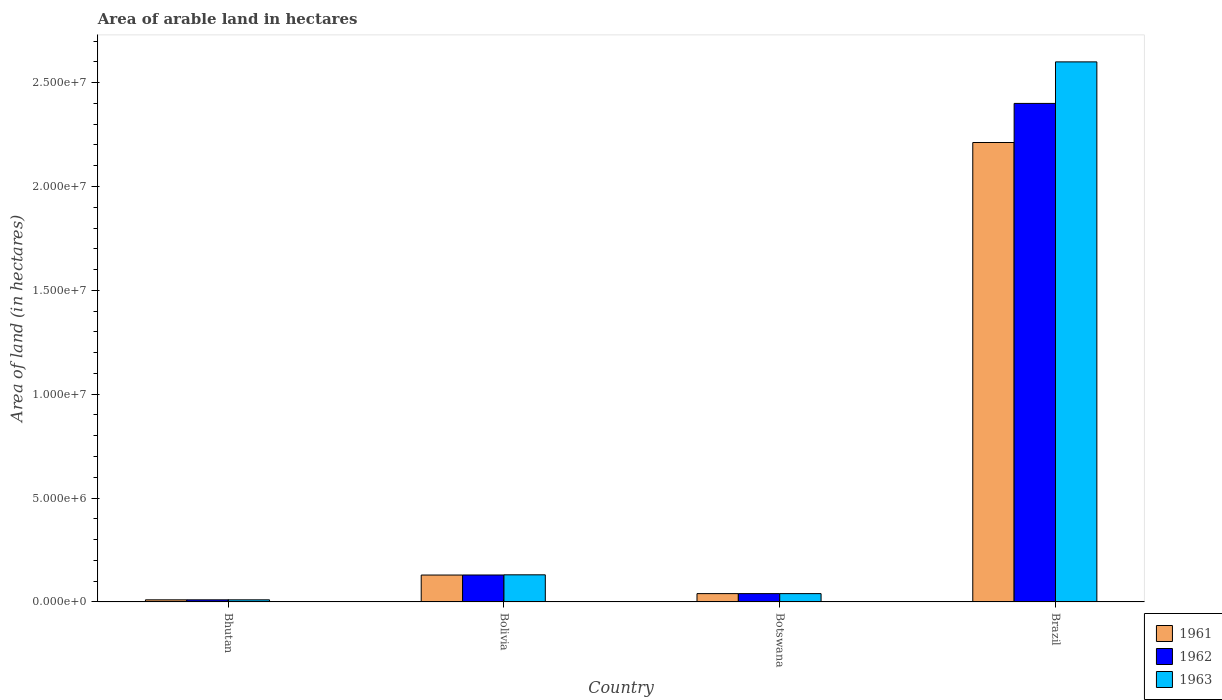How many groups of bars are there?
Offer a very short reply. 4. Are the number of bars per tick equal to the number of legend labels?
Keep it short and to the point. Yes. Are the number of bars on each tick of the X-axis equal?
Your answer should be compact. Yes. How many bars are there on the 1st tick from the right?
Your response must be concise. 3. What is the label of the 2nd group of bars from the left?
Provide a short and direct response. Bolivia. In how many cases, is the number of bars for a given country not equal to the number of legend labels?
Give a very brief answer. 0. What is the total arable land in 1963 in Botswana?
Keep it short and to the point. 3.99e+05. Across all countries, what is the maximum total arable land in 1963?
Give a very brief answer. 2.60e+07. In which country was the total arable land in 1962 minimum?
Keep it short and to the point. Bhutan. What is the total total arable land in 1962 in the graph?
Give a very brief answer. 2.58e+07. What is the difference between the total arable land in 1963 in Bolivia and that in Brazil?
Give a very brief answer. -2.47e+07. What is the difference between the total arable land in 1962 in Brazil and the total arable land in 1961 in Bhutan?
Ensure brevity in your answer.  2.39e+07. What is the average total arable land in 1962 per country?
Provide a succinct answer. 6.45e+06. What is the ratio of the total arable land in 1963 in Bhutan to that in Botswana?
Make the answer very short. 0.25. Is the total arable land in 1962 in Bolivia less than that in Botswana?
Provide a short and direct response. No. What is the difference between the highest and the second highest total arable land in 1962?
Your answer should be compact. 2.27e+07. What is the difference between the highest and the lowest total arable land in 1962?
Provide a short and direct response. 2.39e+07. Is the sum of the total arable land in 1963 in Botswana and Brazil greater than the maximum total arable land in 1961 across all countries?
Make the answer very short. Yes. What does the 1st bar from the right in Brazil represents?
Offer a very short reply. 1963. Are all the bars in the graph horizontal?
Provide a succinct answer. No. Are the values on the major ticks of Y-axis written in scientific E-notation?
Give a very brief answer. Yes. Does the graph contain any zero values?
Ensure brevity in your answer.  No. Where does the legend appear in the graph?
Make the answer very short. Bottom right. What is the title of the graph?
Ensure brevity in your answer.  Area of arable land in hectares. Does "2014" appear as one of the legend labels in the graph?
Your answer should be compact. No. What is the label or title of the Y-axis?
Provide a short and direct response. Area of land (in hectares). What is the Area of land (in hectares) of 1961 in Bhutan?
Your answer should be compact. 1.00e+05. What is the Area of land (in hectares) of 1962 in Bhutan?
Provide a succinct answer. 1.00e+05. What is the Area of land (in hectares) in 1961 in Bolivia?
Ensure brevity in your answer.  1.29e+06. What is the Area of land (in hectares) in 1962 in Bolivia?
Keep it short and to the point. 1.30e+06. What is the Area of land (in hectares) of 1963 in Bolivia?
Your response must be concise. 1.30e+06. What is the Area of land (in hectares) of 1961 in Botswana?
Your answer should be very brief. 3.99e+05. What is the Area of land (in hectares) of 1962 in Botswana?
Provide a succinct answer. 3.99e+05. What is the Area of land (in hectares) in 1963 in Botswana?
Make the answer very short. 3.99e+05. What is the Area of land (in hectares) of 1961 in Brazil?
Ensure brevity in your answer.  2.21e+07. What is the Area of land (in hectares) in 1962 in Brazil?
Provide a succinct answer. 2.40e+07. What is the Area of land (in hectares) in 1963 in Brazil?
Offer a very short reply. 2.60e+07. Across all countries, what is the maximum Area of land (in hectares) in 1961?
Offer a terse response. 2.21e+07. Across all countries, what is the maximum Area of land (in hectares) of 1962?
Keep it short and to the point. 2.40e+07. Across all countries, what is the maximum Area of land (in hectares) in 1963?
Ensure brevity in your answer.  2.60e+07. What is the total Area of land (in hectares) in 1961 in the graph?
Your answer should be compact. 2.39e+07. What is the total Area of land (in hectares) in 1962 in the graph?
Give a very brief answer. 2.58e+07. What is the total Area of land (in hectares) in 1963 in the graph?
Ensure brevity in your answer.  2.78e+07. What is the difference between the Area of land (in hectares) in 1961 in Bhutan and that in Bolivia?
Ensure brevity in your answer.  -1.19e+06. What is the difference between the Area of land (in hectares) of 1962 in Bhutan and that in Bolivia?
Offer a very short reply. -1.20e+06. What is the difference between the Area of land (in hectares) in 1963 in Bhutan and that in Bolivia?
Provide a succinct answer. -1.20e+06. What is the difference between the Area of land (in hectares) in 1961 in Bhutan and that in Botswana?
Your answer should be very brief. -2.99e+05. What is the difference between the Area of land (in hectares) of 1962 in Bhutan and that in Botswana?
Provide a short and direct response. -2.99e+05. What is the difference between the Area of land (in hectares) of 1963 in Bhutan and that in Botswana?
Offer a very short reply. -2.99e+05. What is the difference between the Area of land (in hectares) of 1961 in Bhutan and that in Brazil?
Give a very brief answer. -2.20e+07. What is the difference between the Area of land (in hectares) of 1962 in Bhutan and that in Brazil?
Provide a short and direct response. -2.39e+07. What is the difference between the Area of land (in hectares) of 1963 in Bhutan and that in Brazil?
Make the answer very short. -2.59e+07. What is the difference between the Area of land (in hectares) of 1961 in Bolivia and that in Botswana?
Your answer should be compact. 8.95e+05. What is the difference between the Area of land (in hectares) in 1962 in Bolivia and that in Botswana?
Provide a succinct answer. 8.97e+05. What is the difference between the Area of land (in hectares) in 1963 in Bolivia and that in Botswana?
Offer a terse response. 9.05e+05. What is the difference between the Area of land (in hectares) in 1961 in Bolivia and that in Brazil?
Your response must be concise. -2.08e+07. What is the difference between the Area of land (in hectares) in 1962 in Bolivia and that in Brazil?
Give a very brief answer. -2.27e+07. What is the difference between the Area of land (in hectares) of 1963 in Bolivia and that in Brazil?
Provide a short and direct response. -2.47e+07. What is the difference between the Area of land (in hectares) of 1961 in Botswana and that in Brazil?
Your answer should be compact. -2.17e+07. What is the difference between the Area of land (in hectares) of 1962 in Botswana and that in Brazil?
Your answer should be very brief. -2.36e+07. What is the difference between the Area of land (in hectares) in 1963 in Botswana and that in Brazil?
Make the answer very short. -2.56e+07. What is the difference between the Area of land (in hectares) of 1961 in Bhutan and the Area of land (in hectares) of 1962 in Bolivia?
Your answer should be compact. -1.20e+06. What is the difference between the Area of land (in hectares) in 1961 in Bhutan and the Area of land (in hectares) in 1963 in Bolivia?
Give a very brief answer. -1.20e+06. What is the difference between the Area of land (in hectares) of 1962 in Bhutan and the Area of land (in hectares) of 1963 in Bolivia?
Provide a short and direct response. -1.20e+06. What is the difference between the Area of land (in hectares) in 1961 in Bhutan and the Area of land (in hectares) in 1962 in Botswana?
Provide a succinct answer. -2.99e+05. What is the difference between the Area of land (in hectares) of 1961 in Bhutan and the Area of land (in hectares) of 1963 in Botswana?
Give a very brief answer. -2.99e+05. What is the difference between the Area of land (in hectares) of 1962 in Bhutan and the Area of land (in hectares) of 1963 in Botswana?
Give a very brief answer. -2.99e+05. What is the difference between the Area of land (in hectares) of 1961 in Bhutan and the Area of land (in hectares) of 1962 in Brazil?
Provide a short and direct response. -2.39e+07. What is the difference between the Area of land (in hectares) of 1961 in Bhutan and the Area of land (in hectares) of 1963 in Brazil?
Ensure brevity in your answer.  -2.59e+07. What is the difference between the Area of land (in hectares) of 1962 in Bhutan and the Area of land (in hectares) of 1963 in Brazil?
Offer a terse response. -2.59e+07. What is the difference between the Area of land (in hectares) in 1961 in Bolivia and the Area of land (in hectares) in 1962 in Botswana?
Provide a succinct answer. 8.95e+05. What is the difference between the Area of land (in hectares) in 1961 in Bolivia and the Area of land (in hectares) in 1963 in Botswana?
Keep it short and to the point. 8.95e+05. What is the difference between the Area of land (in hectares) of 1962 in Bolivia and the Area of land (in hectares) of 1963 in Botswana?
Ensure brevity in your answer.  8.97e+05. What is the difference between the Area of land (in hectares) in 1961 in Bolivia and the Area of land (in hectares) in 1962 in Brazil?
Keep it short and to the point. -2.27e+07. What is the difference between the Area of land (in hectares) of 1961 in Bolivia and the Area of land (in hectares) of 1963 in Brazil?
Provide a succinct answer. -2.47e+07. What is the difference between the Area of land (in hectares) in 1962 in Bolivia and the Area of land (in hectares) in 1963 in Brazil?
Make the answer very short. -2.47e+07. What is the difference between the Area of land (in hectares) of 1961 in Botswana and the Area of land (in hectares) of 1962 in Brazil?
Make the answer very short. -2.36e+07. What is the difference between the Area of land (in hectares) in 1961 in Botswana and the Area of land (in hectares) in 1963 in Brazil?
Make the answer very short. -2.56e+07. What is the difference between the Area of land (in hectares) in 1962 in Botswana and the Area of land (in hectares) in 1963 in Brazil?
Provide a short and direct response. -2.56e+07. What is the average Area of land (in hectares) in 1961 per country?
Offer a very short reply. 5.98e+06. What is the average Area of land (in hectares) of 1962 per country?
Provide a short and direct response. 6.45e+06. What is the average Area of land (in hectares) of 1963 per country?
Give a very brief answer. 6.95e+06. What is the difference between the Area of land (in hectares) of 1961 and Area of land (in hectares) of 1962 in Bhutan?
Provide a succinct answer. 0. What is the difference between the Area of land (in hectares) of 1962 and Area of land (in hectares) of 1963 in Bhutan?
Offer a terse response. 0. What is the difference between the Area of land (in hectares) of 1961 and Area of land (in hectares) of 1962 in Bolivia?
Your answer should be very brief. -2000. What is the difference between the Area of land (in hectares) of 1961 and Area of land (in hectares) of 1963 in Bolivia?
Keep it short and to the point. -10000. What is the difference between the Area of land (in hectares) of 1962 and Area of land (in hectares) of 1963 in Bolivia?
Offer a very short reply. -8000. What is the difference between the Area of land (in hectares) of 1961 and Area of land (in hectares) of 1962 in Botswana?
Provide a short and direct response. 0. What is the difference between the Area of land (in hectares) in 1961 and Area of land (in hectares) in 1963 in Botswana?
Your response must be concise. 0. What is the difference between the Area of land (in hectares) of 1961 and Area of land (in hectares) of 1962 in Brazil?
Your answer should be compact. -1.88e+06. What is the difference between the Area of land (in hectares) in 1961 and Area of land (in hectares) in 1963 in Brazil?
Your answer should be compact. -3.88e+06. What is the ratio of the Area of land (in hectares) of 1961 in Bhutan to that in Bolivia?
Your answer should be very brief. 0.08. What is the ratio of the Area of land (in hectares) in 1962 in Bhutan to that in Bolivia?
Provide a succinct answer. 0.08. What is the ratio of the Area of land (in hectares) of 1963 in Bhutan to that in Bolivia?
Your response must be concise. 0.08. What is the ratio of the Area of land (in hectares) of 1961 in Bhutan to that in Botswana?
Offer a terse response. 0.25. What is the ratio of the Area of land (in hectares) in 1962 in Bhutan to that in Botswana?
Offer a terse response. 0.25. What is the ratio of the Area of land (in hectares) in 1963 in Bhutan to that in Botswana?
Provide a succinct answer. 0.25. What is the ratio of the Area of land (in hectares) in 1961 in Bhutan to that in Brazil?
Give a very brief answer. 0. What is the ratio of the Area of land (in hectares) in 1962 in Bhutan to that in Brazil?
Give a very brief answer. 0. What is the ratio of the Area of land (in hectares) of 1963 in Bhutan to that in Brazil?
Provide a short and direct response. 0. What is the ratio of the Area of land (in hectares) in 1961 in Bolivia to that in Botswana?
Keep it short and to the point. 3.24. What is the ratio of the Area of land (in hectares) in 1962 in Bolivia to that in Botswana?
Your answer should be very brief. 3.25. What is the ratio of the Area of land (in hectares) in 1963 in Bolivia to that in Botswana?
Your response must be concise. 3.27. What is the ratio of the Area of land (in hectares) of 1961 in Bolivia to that in Brazil?
Your answer should be compact. 0.06. What is the ratio of the Area of land (in hectares) of 1962 in Bolivia to that in Brazil?
Provide a short and direct response. 0.05. What is the ratio of the Area of land (in hectares) in 1963 in Bolivia to that in Brazil?
Ensure brevity in your answer.  0.05. What is the ratio of the Area of land (in hectares) in 1961 in Botswana to that in Brazil?
Offer a very short reply. 0.02. What is the ratio of the Area of land (in hectares) of 1962 in Botswana to that in Brazil?
Provide a short and direct response. 0.02. What is the ratio of the Area of land (in hectares) in 1963 in Botswana to that in Brazil?
Provide a short and direct response. 0.02. What is the difference between the highest and the second highest Area of land (in hectares) of 1961?
Provide a short and direct response. 2.08e+07. What is the difference between the highest and the second highest Area of land (in hectares) of 1962?
Keep it short and to the point. 2.27e+07. What is the difference between the highest and the second highest Area of land (in hectares) in 1963?
Offer a terse response. 2.47e+07. What is the difference between the highest and the lowest Area of land (in hectares) of 1961?
Your answer should be very brief. 2.20e+07. What is the difference between the highest and the lowest Area of land (in hectares) in 1962?
Offer a terse response. 2.39e+07. What is the difference between the highest and the lowest Area of land (in hectares) in 1963?
Offer a very short reply. 2.59e+07. 